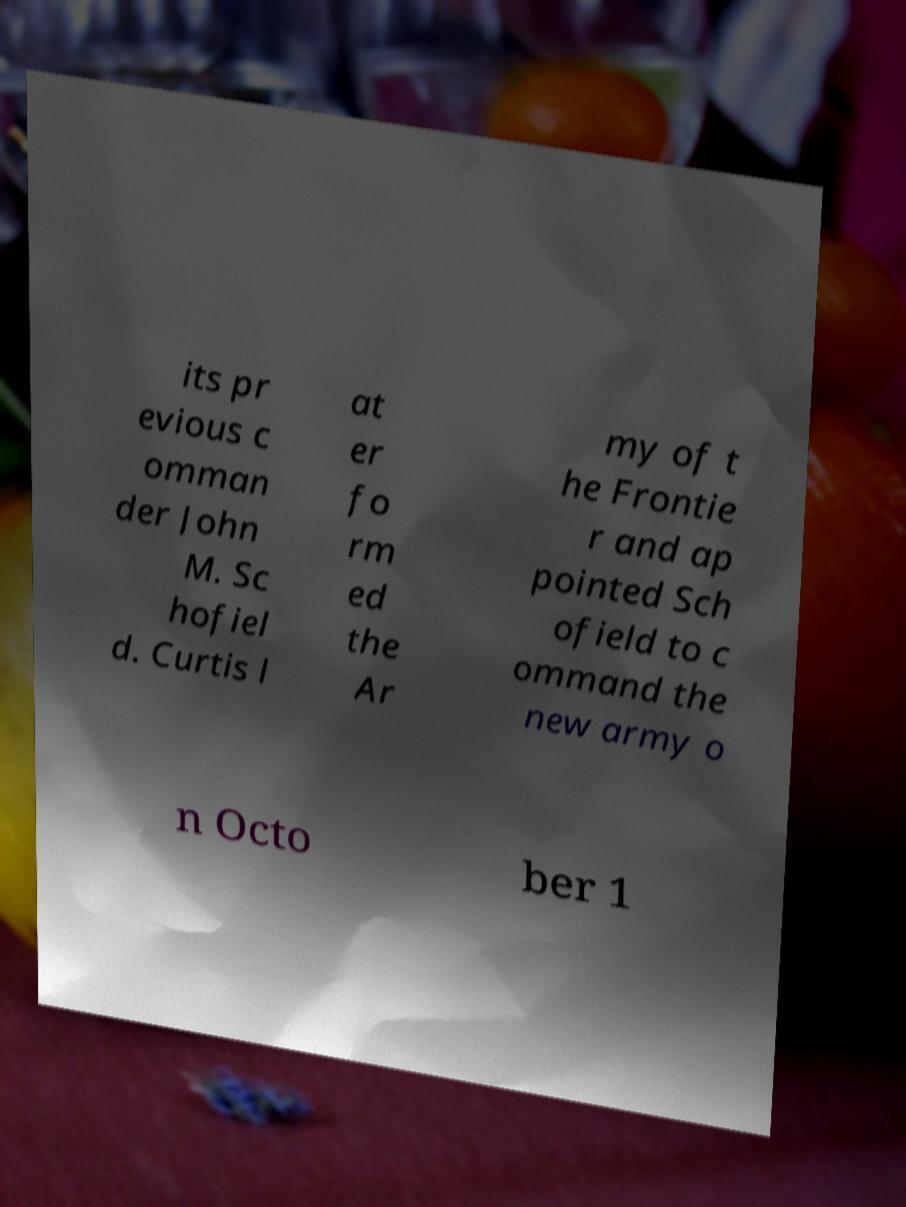For documentation purposes, I need the text within this image transcribed. Could you provide that? its pr evious c omman der John M. Sc hofiel d. Curtis l at er fo rm ed the Ar my of t he Frontie r and ap pointed Sch ofield to c ommand the new army o n Octo ber 1 